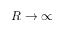Convert formula to latex. <formula><loc_0><loc_0><loc_500><loc_500>R \rightarrow \infty</formula> 